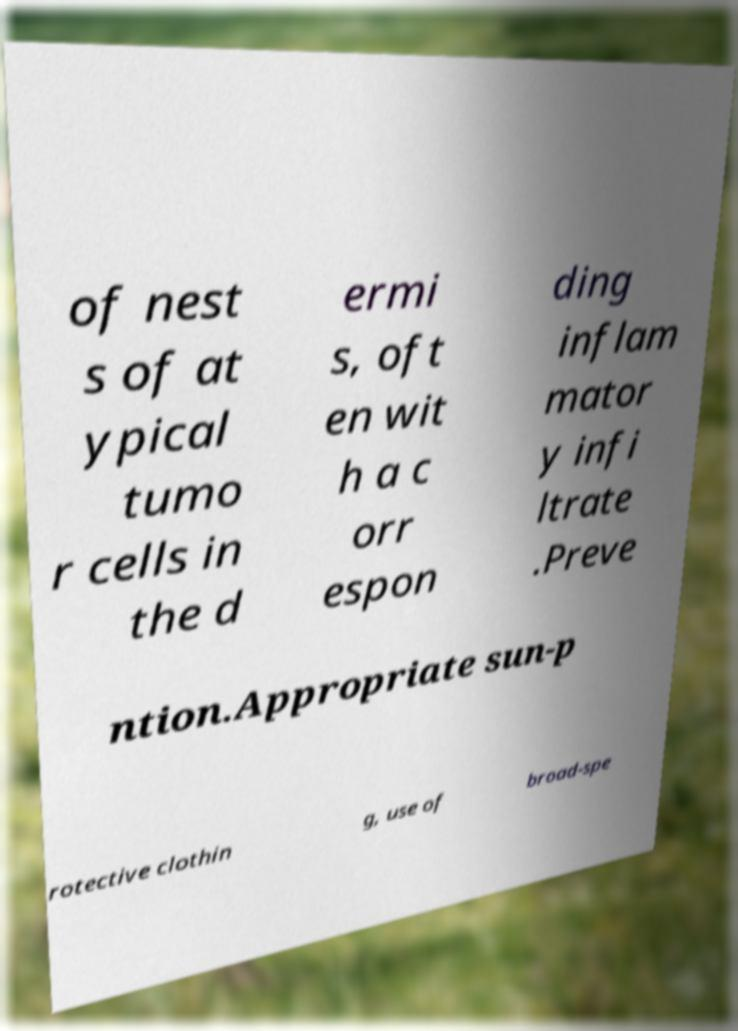Could you extract and type out the text from this image? of nest s of at ypical tumo r cells in the d ermi s, oft en wit h a c orr espon ding inflam mator y infi ltrate .Preve ntion.Appropriate sun-p rotective clothin g, use of broad-spe 